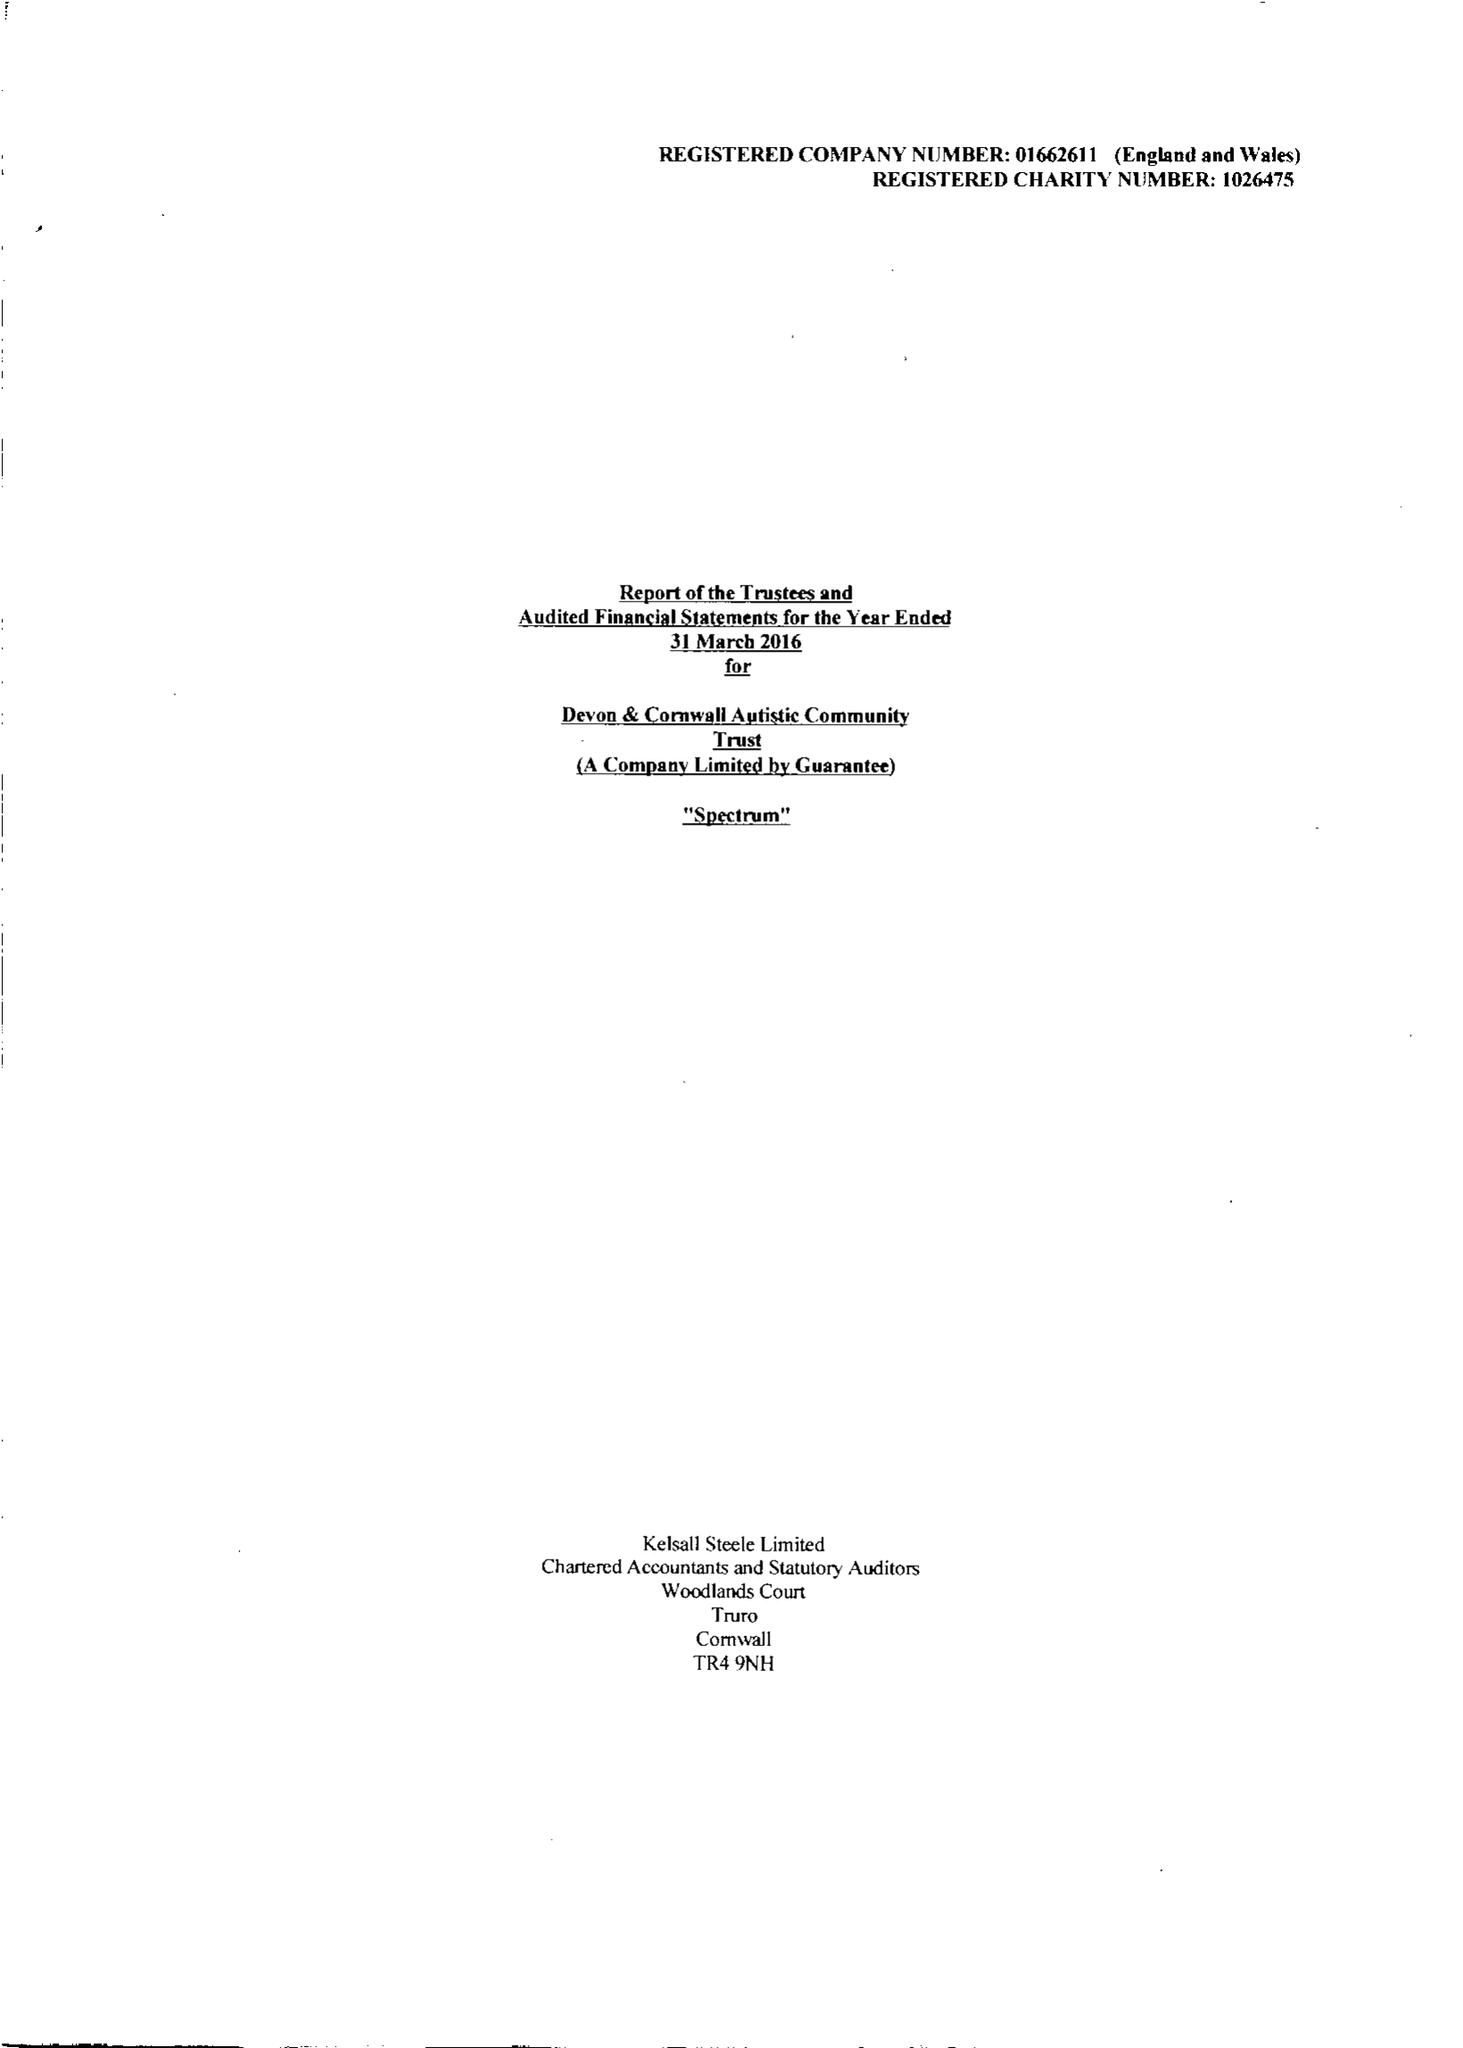What is the value for the address__postcode?
Answer the question using a single word or phrase. TR13 0SR 